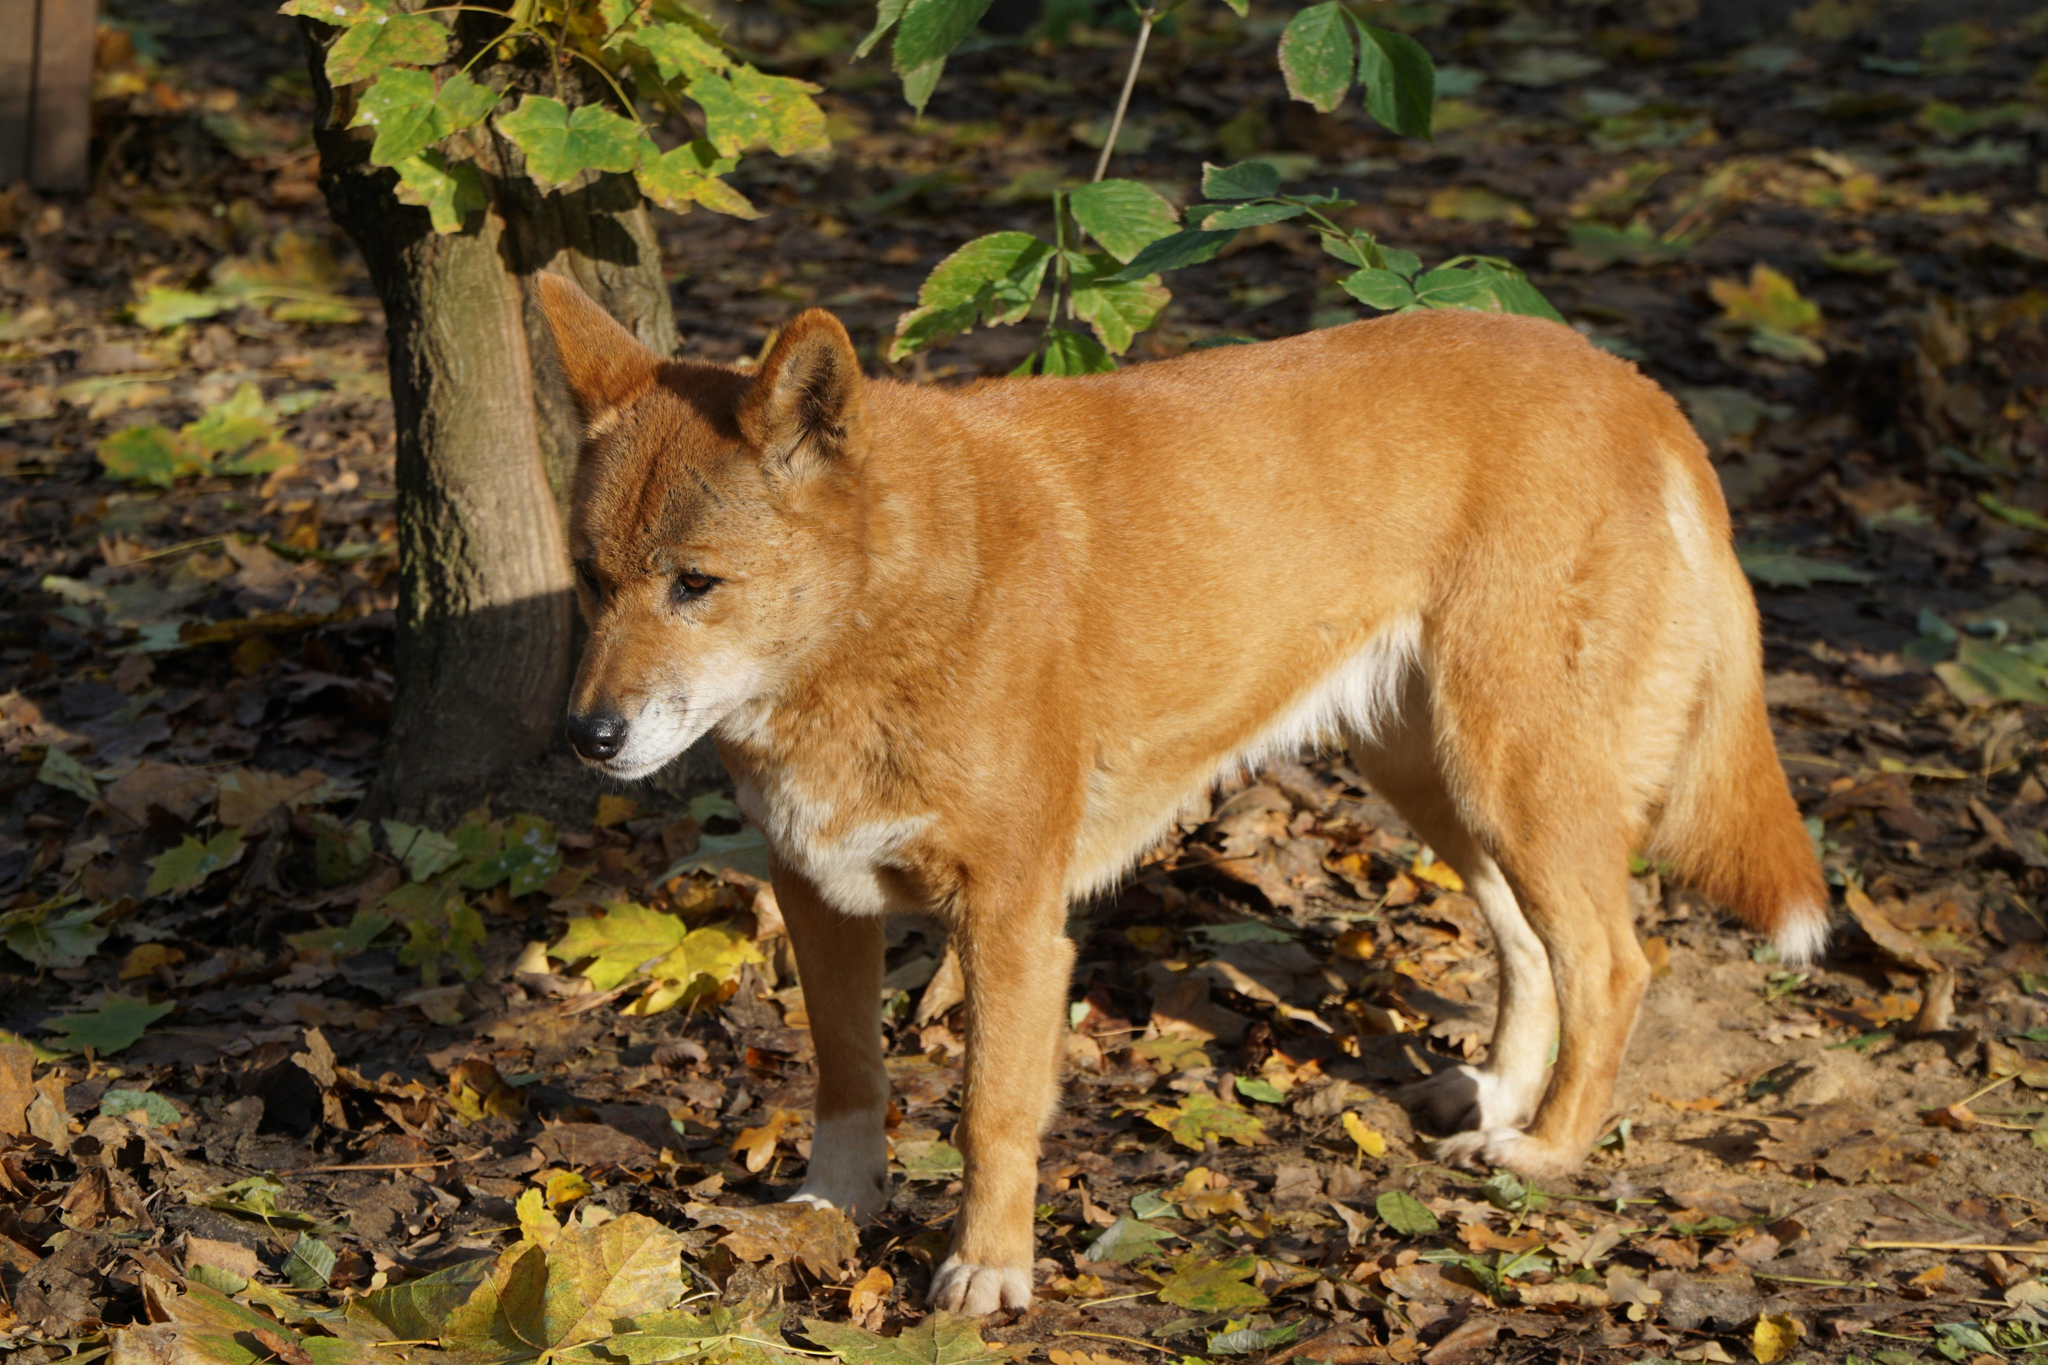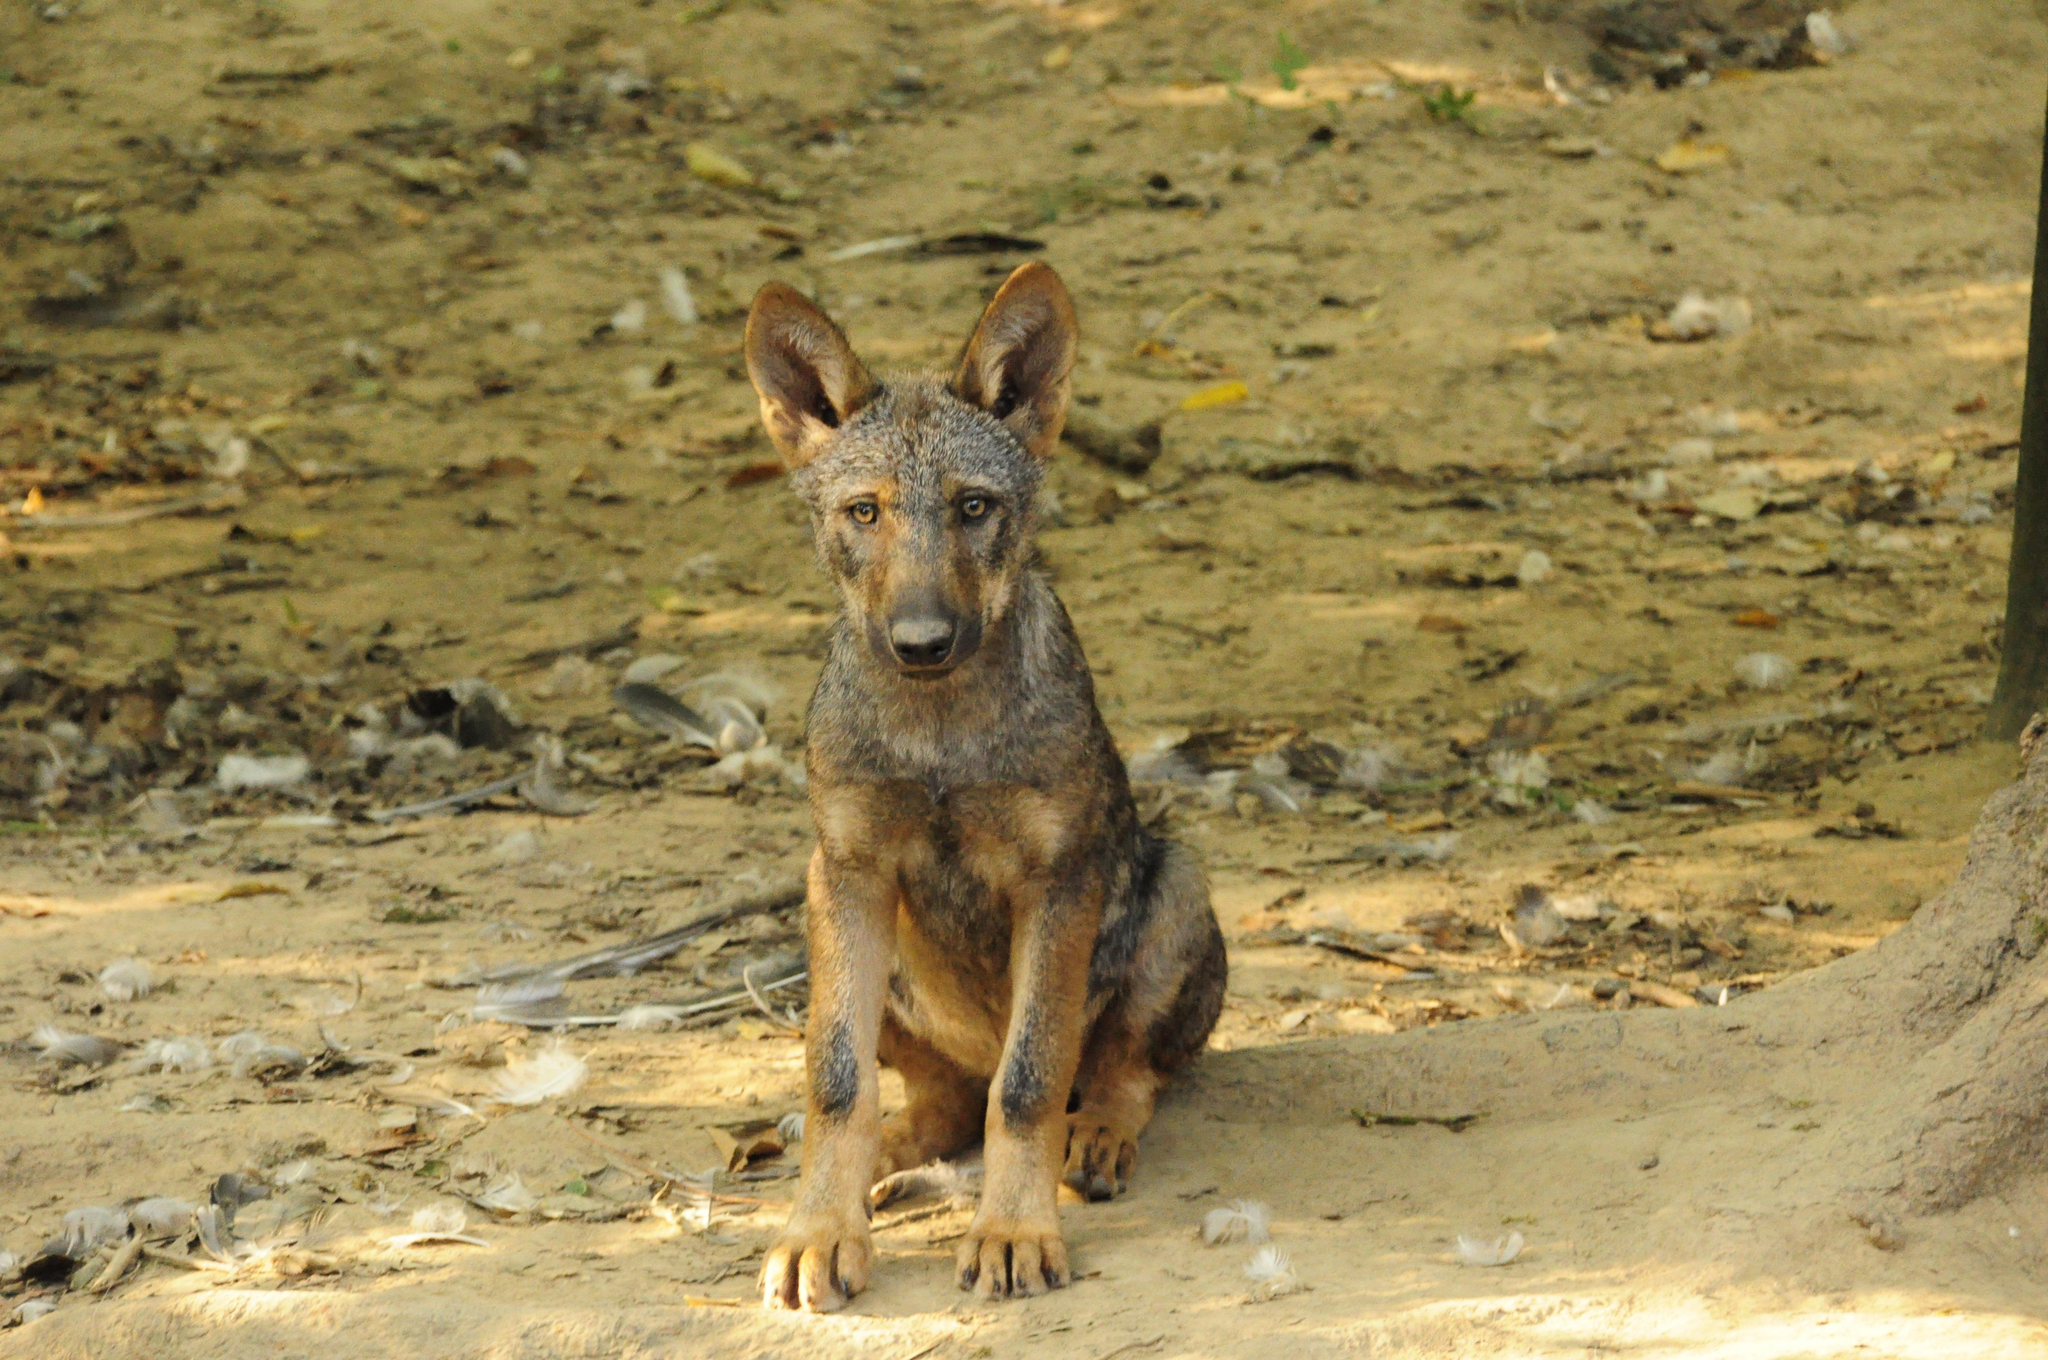The first image is the image on the left, the second image is the image on the right. Assess this claim about the two images: "There are two dogs in grassy areas.". Correct or not? Answer yes or no. No. The first image is the image on the left, the second image is the image on the right. Considering the images on both sides, is "Each image contains one open-eyed dog, and the dogs in the left and right images appear to look toward each other." valid? Answer yes or no. No. 